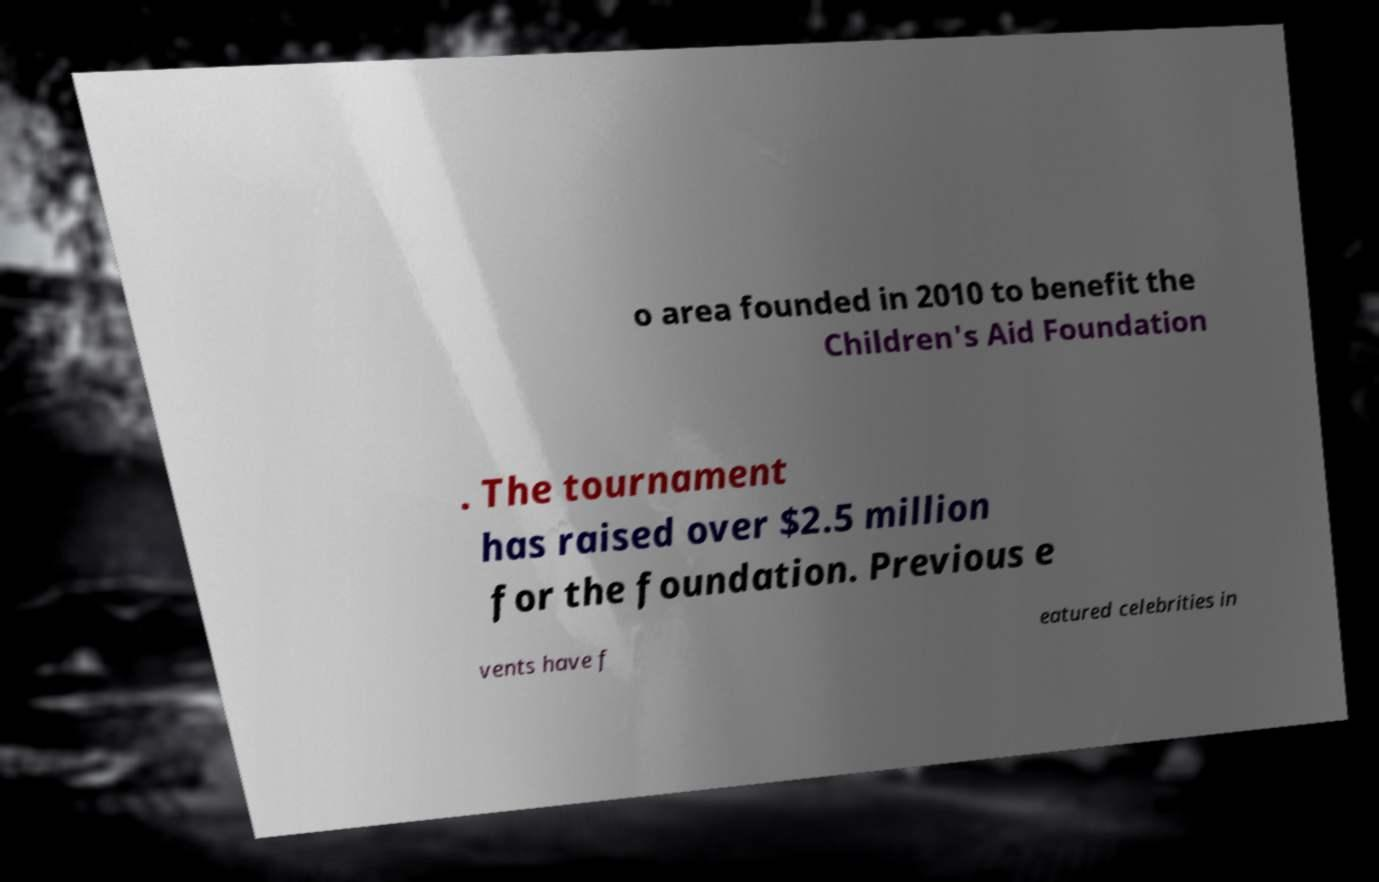Could you extract and type out the text from this image? o area founded in 2010 to benefit the Children's Aid Foundation . The tournament has raised over $2.5 million for the foundation. Previous e vents have f eatured celebrities in 